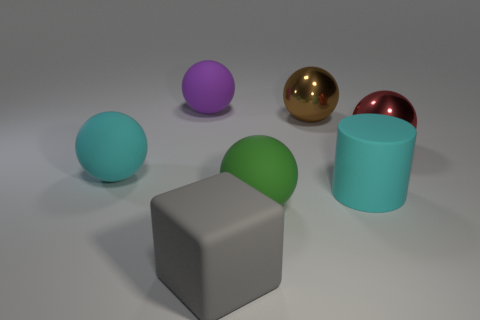Subtract all big cyan matte spheres. How many spheres are left? 4 Subtract all purple balls. How many balls are left? 4 Subtract all yellow balls. Subtract all red cylinders. How many balls are left? 5 Add 2 small purple balls. How many objects exist? 9 Subtract all spheres. How many objects are left? 2 Subtract 1 cyan balls. How many objects are left? 6 Subtract all gray matte things. Subtract all big red things. How many objects are left? 5 Add 3 big metallic things. How many big metallic things are left? 5 Add 1 big green rubber balls. How many big green rubber balls exist? 2 